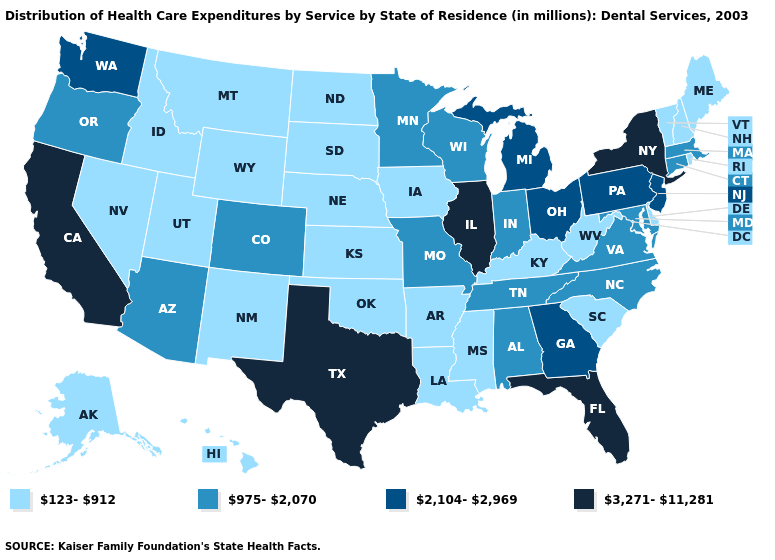Does Massachusetts have the lowest value in the Northeast?
Quick response, please. No. What is the value of Idaho?
Quick response, please. 123-912. What is the lowest value in the West?
Give a very brief answer. 123-912. Is the legend a continuous bar?
Answer briefly. No. Among the states that border Kentucky , does Ohio have the lowest value?
Answer briefly. No. What is the lowest value in states that border New Hampshire?
Quick response, please. 123-912. What is the value of Vermont?
Keep it brief. 123-912. What is the highest value in the USA?
Answer briefly. 3,271-11,281. Does California have the highest value in the West?
Concise answer only. Yes. What is the highest value in states that border New York?
Be succinct. 2,104-2,969. Name the states that have a value in the range 2,104-2,969?
Give a very brief answer. Georgia, Michigan, New Jersey, Ohio, Pennsylvania, Washington. Does Delaware have a lower value than Arizona?
Be succinct. Yes. Does the first symbol in the legend represent the smallest category?
Be succinct. Yes. Name the states that have a value in the range 3,271-11,281?
Keep it brief. California, Florida, Illinois, New York, Texas. Does Nevada have the lowest value in the West?
Concise answer only. Yes. 